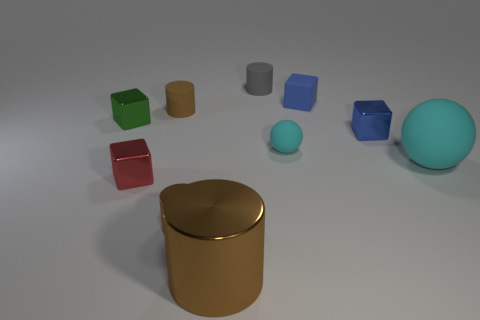What number of cylinders are red objects or big cyan rubber things?
Your answer should be very brief. 0. There is a large thing that is the same color as the small metal cylinder; what is it made of?
Your answer should be compact. Metal. There is a small matte thing that is left of the gray thing; is its shape the same as the tiny metal thing that is on the right side of the small cyan matte thing?
Your answer should be very brief. No. What color is the tiny block that is both in front of the blue matte object and right of the big cylinder?
Give a very brief answer. Blue. Does the tiny rubber cube have the same color as the small matte object that is in front of the green shiny object?
Your answer should be very brief. No. What size is the rubber object that is on the right side of the small cyan thing and on the left side of the large matte object?
Offer a very short reply. Small. How many other things are there of the same color as the big cylinder?
Your answer should be compact. 2. What is the size of the blue object that is in front of the brown cylinder behind the small metallic cube left of the small red shiny object?
Your answer should be compact. Small. Are there any gray matte things on the right side of the large cyan thing?
Give a very brief answer. No. Do the blue shiny thing and the brown shiny thing that is behind the big brown object have the same size?
Offer a very short reply. Yes. 